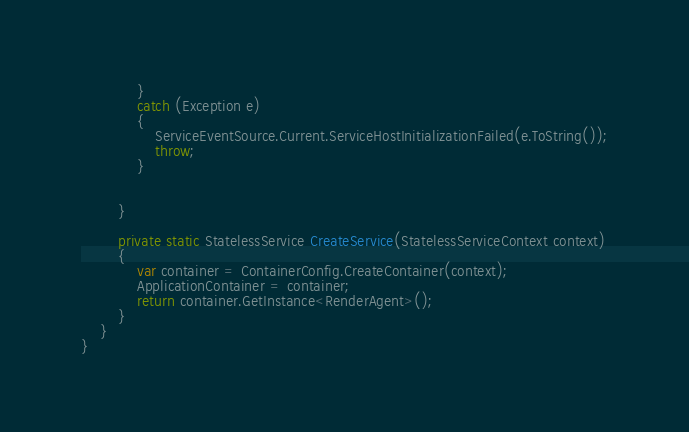<code> <loc_0><loc_0><loc_500><loc_500><_C#_>            }
            catch (Exception e)
            {
                ServiceEventSource.Current.ServiceHostInitializationFailed(e.ToString());
                throw;
            }


        }

        private static StatelessService CreateService(StatelessServiceContext context)
        {
            var container = ContainerConfig.CreateContainer(context);
            ApplicationContainer = container;
            return container.GetInstance<RenderAgent>();
        }
    }
}
</code> 